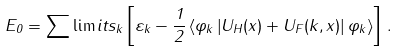Convert formula to latex. <formula><loc_0><loc_0><loc_500><loc_500>E _ { 0 } = \sum \lim i t s _ { k } \left [ \varepsilon _ { k } - \frac { 1 } { 2 } \left \langle \varphi _ { k } \left | U _ { H } ( x ) + U _ { F } ( k , x ) \right | \varphi _ { k } \right \rangle \right ] \, .</formula> 